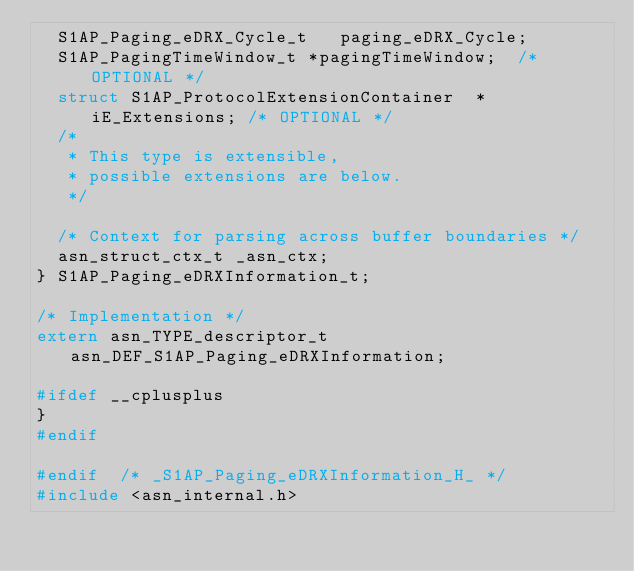<code> <loc_0><loc_0><loc_500><loc_500><_C_>	S1AP_Paging_eDRX_Cycle_t	 paging_eDRX_Cycle;
	S1AP_PagingTimeWindow_t	*pagingTimeWindow;	/* OPTIONAL */
	struct S1AP_ProtocolExtensionContainer	*iE_Extensions;	/* OPTIONAL */
	/*
	 * This type is extensible,
	 * possible extensions are below.
	 */
	
	/* Context for parsing across buffer boundaries */
	asn_struct_ctx_t _asn_ctx;
} S1AP_Paging_eDRXInformation_t;

/* Implementation */
extern asn_TYPE_descriptor_t asn_DEF_S1AP_Paging_eDRXInformation;

#ifdef __cplusplus
}
#endif

#endif	/* _S1AP_Paging_eDRXInformation_H_ */
#include <asn_internal.h>
</code> 